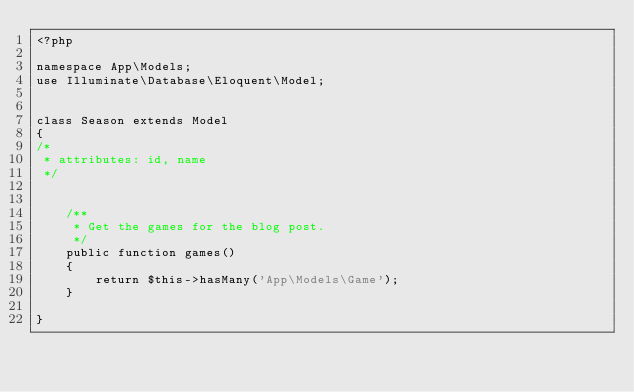Convert code to text. <code><loc_0><loc_0><loc_500><loc_500><_PHP_><?php

namespace App\Models;
use Illuminate\Database\Eloquent\Model;


class Season extends Model
{
/*
 * attributes: id, name
 */


    /**
     * Get the games for the blog post.
     */
    public function games()
    {
        return $this->hasMany('App\Models\Game');
    }

}
</code> 